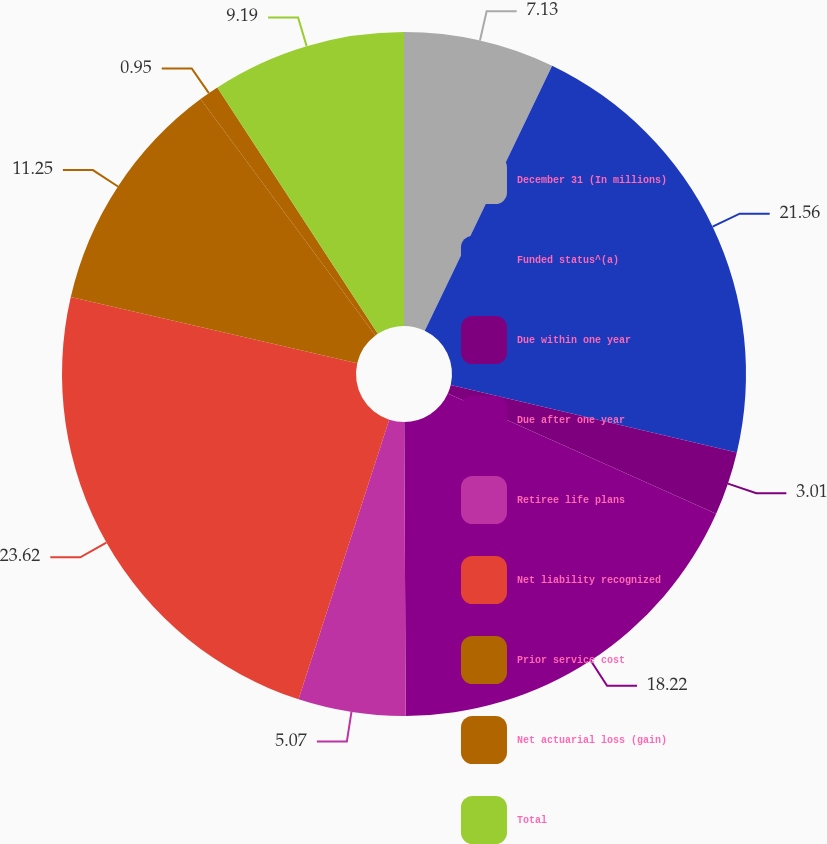<chart> <loc_0><loc_0><loc_500><loc_500><pie_chart><fcel>December 31 (In millions)<fcel>Funded status^(a)<fcel>Due within one year<fcel>Due after one year<fcel>Retiree life plans<fcel>Net liability recognized<fcel>Prior service cost<fcel>Net actuarial loss (gain)<fcel>Total<nl><fcel>7.13%<fcel>21.56%<fcel>3.01%<fcel>18.22%<fcel>5.07%<fcel>23.62%<fcel>11.25%<fcel>0.95%<fcel>9.19%<nl></chart> 